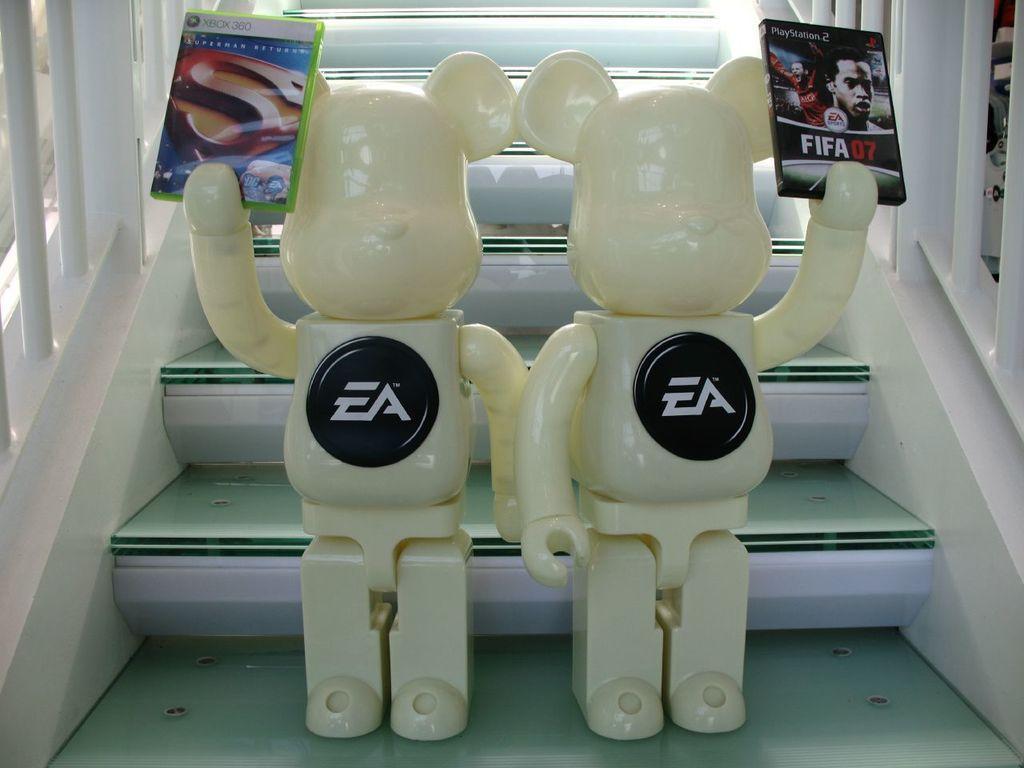Can you describe this image briefly? In this image there are two toys holding books in hands and standing on the stairs. 